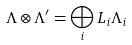Convert formula to latex. <formula><loc_0><loc_0><loc_500><loc_500>\Lambda \otimes \Lambda ^ { \prime } = \bigoplus _ { i } L _ { i } \Lambda _ { i }</formula> 